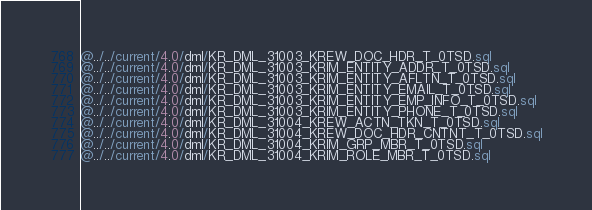<code> <loc_0><loc_0><loc_500><loc_500><_SQL_>@../../current/4.0/dml/KR_DML_31003_KREW_DOC_HDR_T_0TSD.sql
@../../current/4.0/dml/KR_DML_31003_KRIM_ENTITY_ADDR_T_0TSD.sql
@../../current/4.0/dml/KR_DML_31003_KRIM_ENTITY_AFLTN_T_0TSD.sql
@../../current/4.0/dml/KR_DML_31003_KRIM_ENTITY_EMAIL_T_0TSD.sql
@../../current/4.0/dml/KR_DML_31003_KRIM_ENTITY_EMP_INFO_T_0TSD.sql
@../../current/4.0/dml/KR_DML_31003_KRIM_ENTITY_PHONE_T_0TSD.sql
@../../current/4.0/dml/KR_DML_31004_KREW_ACTN_TKN_T_0TSD.sql
@../../current/4.0/dml/KR_DML_31004_KREW_DOC_HDR_CNTNT_T_0TSD.sql
@../../current/4.0/dml/KR_DML_31004_KRIM_GRP_MBR_T_0TSD.sql
@../../current/4.0/dml/KR_DML_31004_KRIM_ROLE_MBR_T_0TSD.sql</code> 